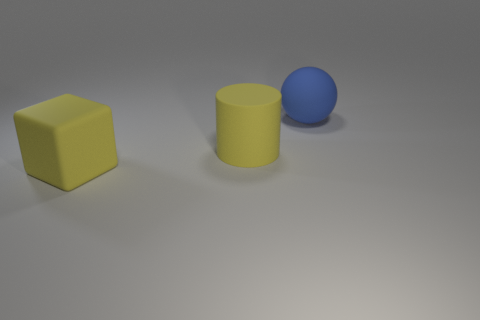Are there any other things that are the same shape as the big blue matte object?
Make the answer very short. No. There is a thing that is in front of the blue object and to the right of the large yellow rubber block; what is its material?
Ensure brevity in your answer.  Rubber. Is the number of matte cubes greater than the number of yellow things?
Give a very brief answer. No. What color is the big matte thing to the right of the large yellow thing right of the big yellow thing in front of the big matte cylinder?
Keep it short and to the point. Blue. Are the big yellow object that is behind the cube and the big yellow block made of the same material?
Your answer should be very brief. Yes. Is there a rubber ball that has the same color as the block?
Your response must be concise. No. Are any brown matte spheres visible?
Offer a terse response. No. Are there fewer large blue spheres than big yellow things?
Make the answer very short. Yes. What shape is the big yellow object behind the large yellow object that is on the left side of the large yellow matte object that is behind the large yellow rubber block?
Provide a succinct answer. Cylinder. Are there any other large blue spheres that have the same material as the blue ball?
Give a very brief answer. No. 